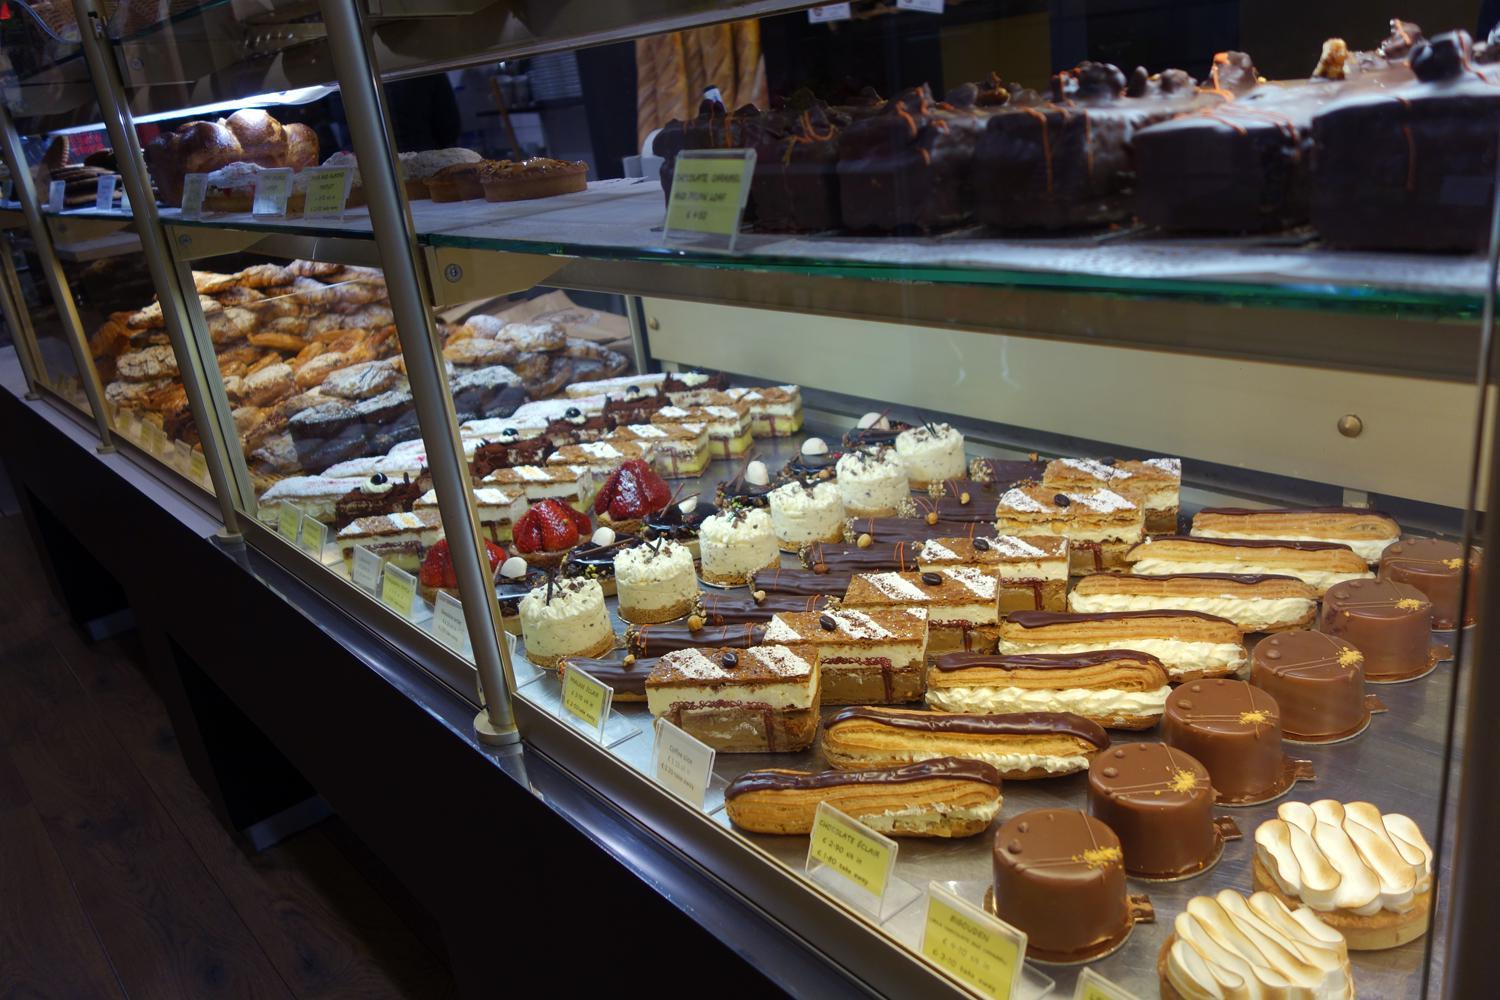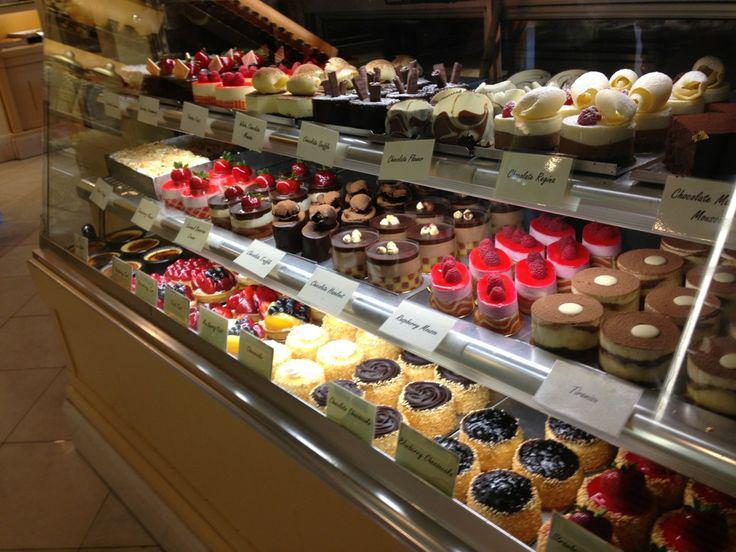The first image is the image on the left, the second image is the image on the right. Evaluate the accuracy of this statement regarding the images: "The display case on the right contains mostly round cake-like desserts that aren't covered in sliced fruits.". Is it true? Answer yes or no. Yes. The first image is the image on the left, the second image is the image on the right. Examine the images to the left and right. Is the description "some of the pastries have strawberries on top." accurate? Answer yes or no. Yes. 